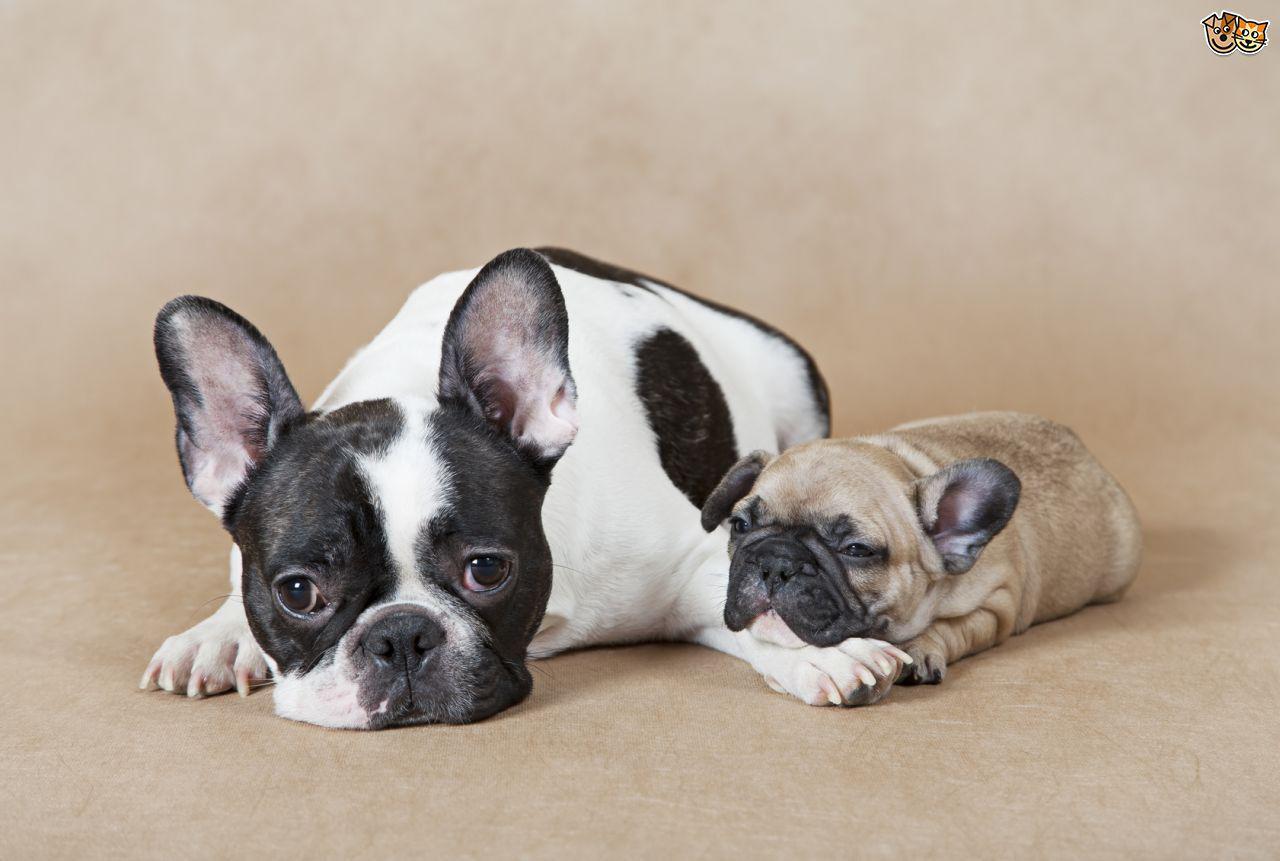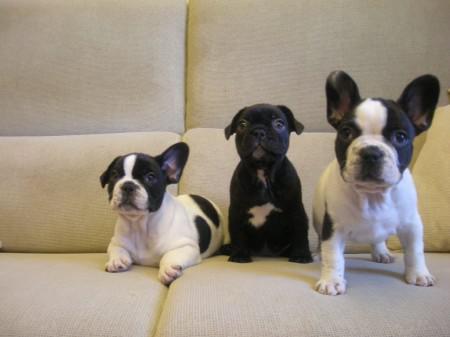The first image is the image on the left, the second image is the image on the right. Evaluate the accuracy of this statement regarding the images: "There are two dogs". Is it true? Answer yes or no. No. The first image is the image on the left, the second image is the image on the right. For the images displayed, is the sentence "There are two dogs shown in total." factually correct? Answer yes or no. No. 